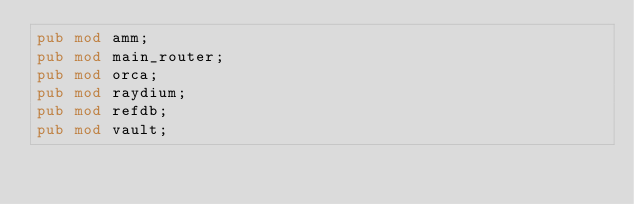Convert code to text. <code><loc_0><loc_0><loc_500><loc_500><_Rust_>pub mod amm;
pub mod main_router;
pub mod orca;
pub mod raydium;
pub mod refdb;
pub mod vault;
</code> 